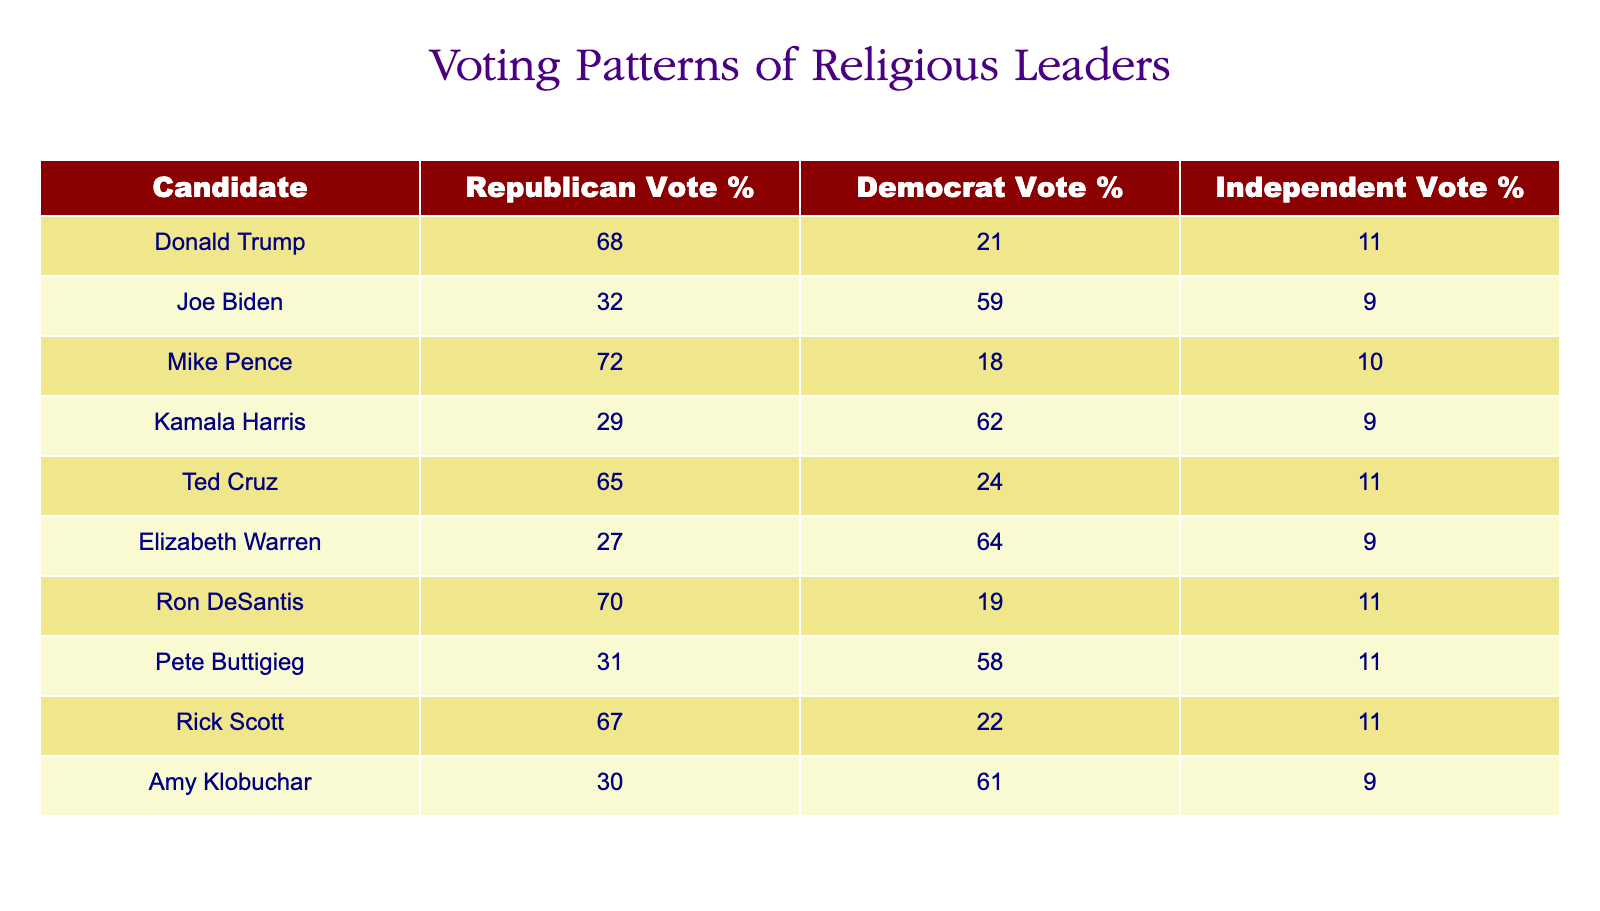What is the Republican vote percentage for Donald Trump? The table states that Donald Trump has a Republican vote percentage of 68%.
Answer: 68 Which candidate received the highest Democratic vote percentage? By reviewing the table, Joe Biden has the highest Democratic vote percentage at 59%.
Answer: Joe Biden What is the average Independent vote percentage across all candidates? To find the average, add up all the Independent vote percentages: (11 + 9 + 10 + 9 + 11 + 9 + 11 + 11 + 11 + 9) = 100. There are 10 candidates, so the average is 100/10 = 10.
Answer: 10 Did Kamala Harris receive a higher Democratic vote percentage than Elizabeth Warren? Based on the table, Kamala Harris has a Democratic vote percentage of 62%, while Elizabeth Warren has 64%. Thus, Kamala Harris did not receive a higher percentage than Warren.
Answer: No Which candidate received the lowest Republican vote percentage among all the candidates listed? The table indicates that the candidate with the lowest Republican vote percentage is Elizabeth Warren, with 27%.
Answer: Elizabeth Warren What is the total Republican vote percentage for Mike Pence and Ted Cruz combined? The Republican vote percentage for Mike Pence is 72% and for Ted Cruz is 65%. Adding these together gives 72 + 65 = 137%.
Answer: 137% Is there a candidate who received both a Republican and Independent vote percentage of over 70%? By looking at the table, Ron DeSantis has a Republican vote percentage of 70% and an Independent vote percentage of 11%. No candidate exceeds 70% in both categories.
Answer: No What is the difference between the Republican vote percentage of Rick Scott and the Independent vote percentage of Amy Klobuchar? Rick Scott has a Republican vote percentage of 67%, while Amy Klobuchar has an Independent vote percentage of 9%. The difference is 67 - 9 = 58%.
Answer: 58 Which candidate has the most balanced vote share between the Republican and Democrat categories? Evaluating the Republican and Democrat percentages for each candidate, Pete Buttigieg has a Republican vote percentage of 31% and a Democratic vote percentage of 58%, resulting in the most balanced difference of 27%.
Answer: Pete Buttigieg 